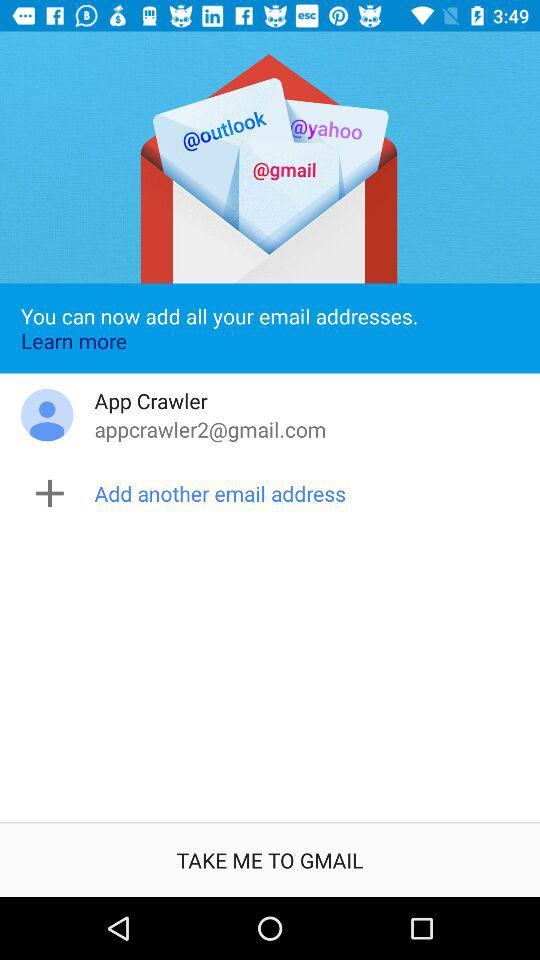What is the user's contact phone number?
When the provided information is insufficient, respond with <no answer>. <no answer> 